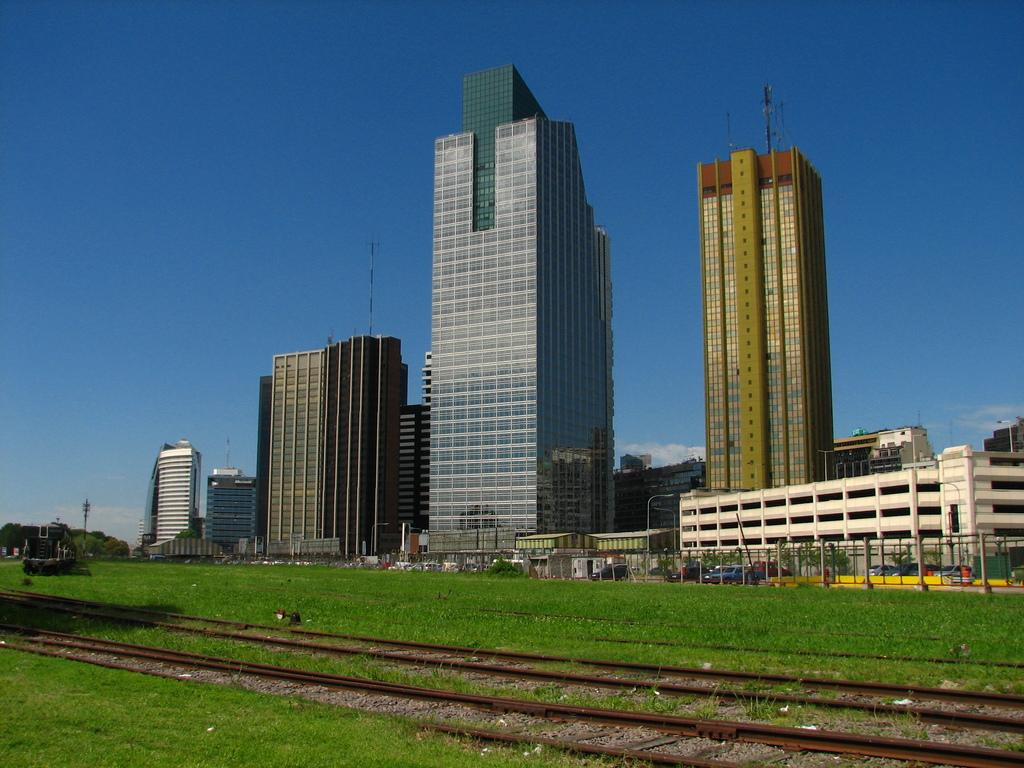What type of surface can be seen in the image? There are there any tracks visible? What type of natural environment is present in the image? There is grass in the image. What type of structures can be seen in the image? There are buildings in the image. What type of vegetation is present in the image? There are trees in the image. What type of man-made objects can be seen in the image? There are vehicles in the image. What type of barrier is present in the image? There is a fence in the image. How long does it take for the beam to pass through the image? There is no beam present in the image, so it cannot be determined how long it would take for it to pass through. 